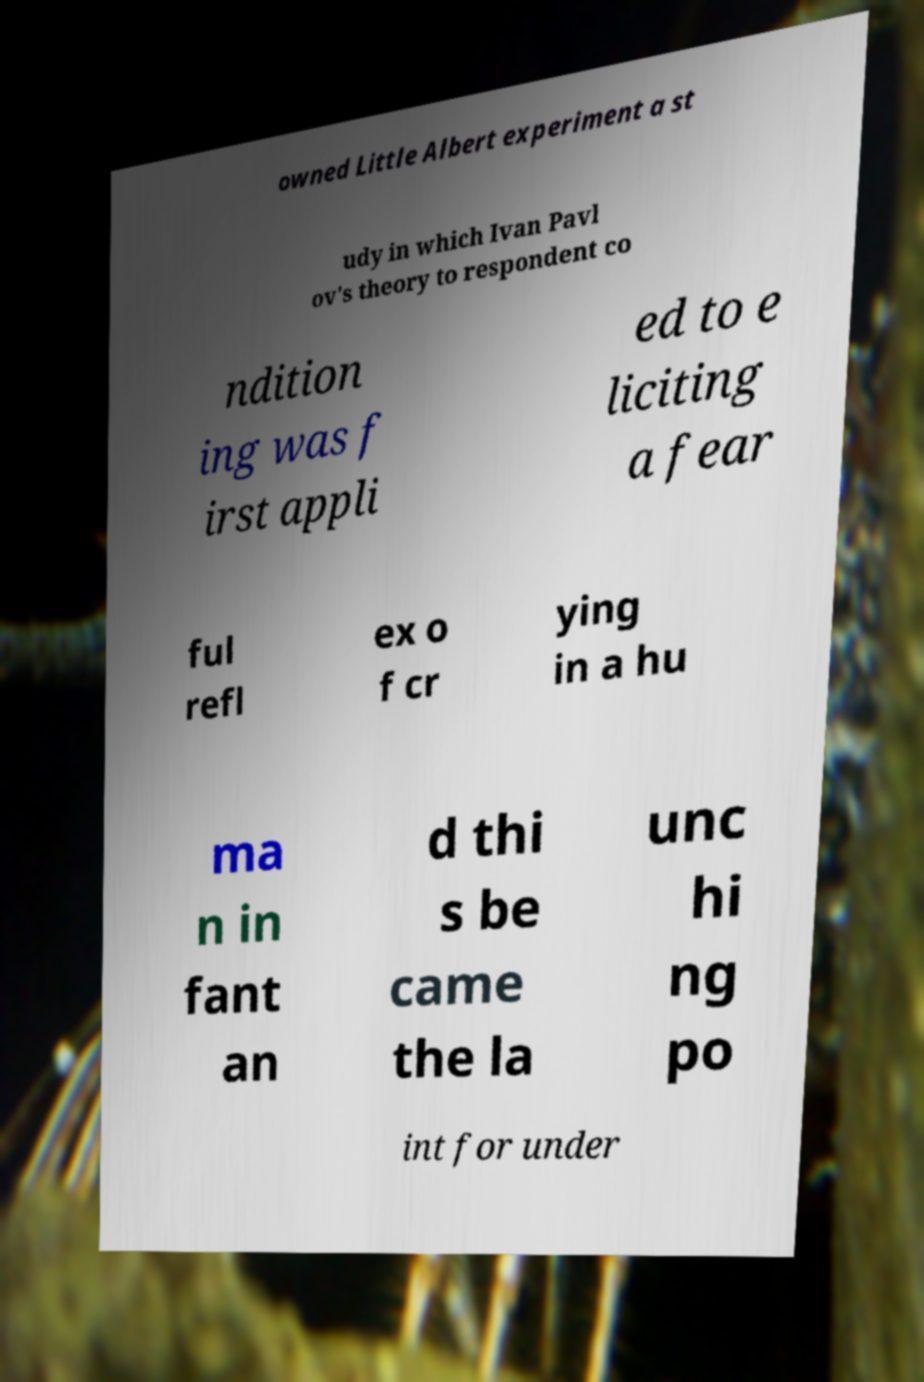Could you extract and type out the text from this image? owned Little Albert experiment a st udy in which Ivan Pavl ov's theory to respondent co ndition ing was f irst appli ed to e liciting a fear ful refl ex o f cr ying in a hu ma n in fant an d thi s be came the la unc hi ng po int for under 